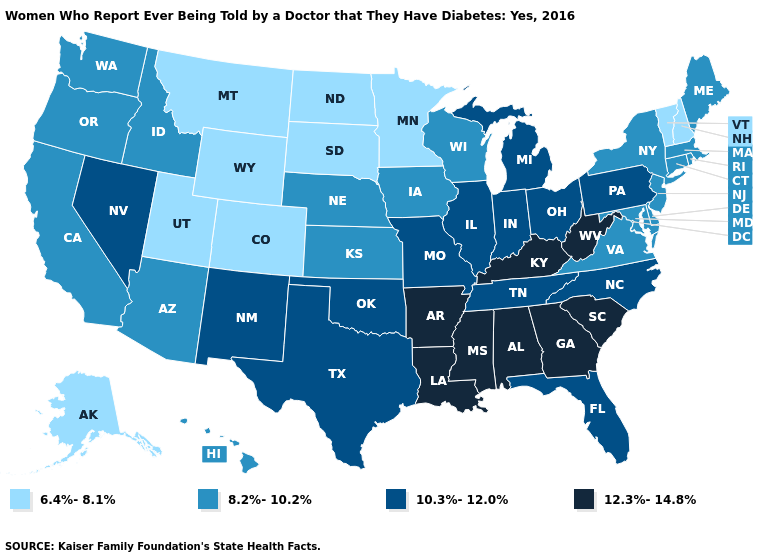What is the value of North Dakota?
Answer briefly. 6.4%-8.1%. Which states have the highest value in the USA?
Keep it brief. Alabama, Arkansas, Georgia, Kentucky, Louisiana, Mississippi, South Carolina, West Virginia. Which states have the lowest value in the South?
Answer briefly. Delaware, Maryland, Virginia. Which states have the highest value in the USA?
Be succinct. Alabama, Arkansas, Georgia, Kentucky, Louisiana, Mississippi, South Carolina, West Virginia. What is the lowest value in states that border Maryland?
Be succinct. 8.2%-10.2%. Name the states that have a value in the range 8.2%-10.2%?
Quick response, please. Arizona, California, Connecticut, Delaware, Hawaii, Idaho, Iowa, Kansas, Maine, Maryland, Massachusetts, Nebraska, New Jersey, New York, Oregon, Rhode Island, Virginia, Washington, Wisconsin. What is the lowest value in the USA?
Answer briefly. 6.4%-8.1%. Name the states that have a value in the range 10.3%-12.0%?
Answer briefly. Florida, Illinois, Indiana, Michigan, Missouri, Nevada, New Mexico, North Carolina, Ohio, Oklahoma, Pennsylvania, Tennessee, Texas. Among the states that border New Jersey , which have the highest value?
Keep it brief. Pennsylvania. What is the lowest value in the USA?
Short answer required. 6.4%-8.1%. Does Pennsylvania have a higher value than Maine?
Concise answer only. Yes. Name the states that have a value in the range 8.2%-10.2%?
Concise answer only. Arizona, California, Connecticut, Delaware, Hawaii, Idaho, Iowa, Kansas, Maine, Maryland, Massachusetts, Nebraska, New Jersey, New York, Oregon, Rhode Island, Virginia, Washington, Wisconsin. Among the states that border Washington , which have the highest value?
Keep it brief. Idaho, Oregon. Does North Dakota have the lowest value in the MidWest?
Short answer required. Yes. What is the value of Colorado?
Answer briefly. 6.4%-8.1%. 